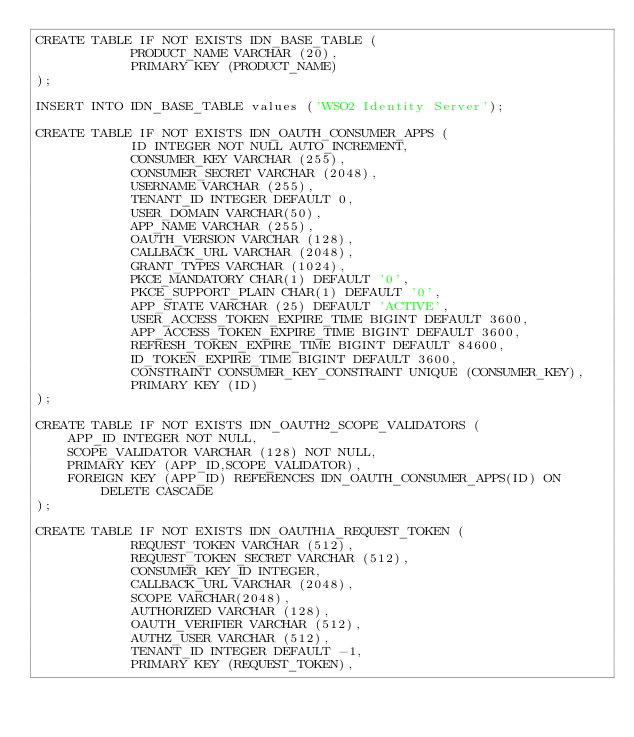<code> <loc_0><loc_0><loc_500><loc_500><_SQL_>CREATE TABLE IF NOT EXISTS IDN_BASE_TABLE (
            PRODUCT_NAME VARCHAR (20),
            PRIMARY KEY (PRODUCT_NAME)
);

INSERT INTO IDN_BASE_TABLE values ('WSO2 Identity Server');

CREATE TABLE IF NOT EXISTS IDN_OAUTH_CONSUMER_APPS (
            ID INTEGER NOT NULL AUTO_INCREMENT,
            CONSUMER_KEY VARCHAR (255),
            CONSUMER_SECRET VARCHAR (2048),
            USERNAME VARCHAR (255),
            TENANT_ID INTEGER DEFAULT 0,
            USER_DOMAIN VARCHAR(50),
            APP_NAME VARCHAR (255),
            OAUTH_VERSION VARCHAR (128),
            CALLBACK_URL VARCHAR (2048),
            GRANT_TYPES VARCHAR (1024),
            PKCE_MANDATORY CHAR(1) DEFAULT '0',
            PKCE_SUPPORT_PLAIN CHAR(1) DEFAULT '0',
            APP_STATE VARCHAR (25) DEFAULT 'ACTIVE',
            USER_ACCESS_TOKEN_EXPIRE_TIME BIGINT DEFAULT 3600,
            APP_ACCESS_TOKEN_EXPIRE_TIME BIGINT DEFAULT 3600,
            REFRESH_TOKEN_EXPIRE_TIME BIGINT DEFAULT 84600,
            ID_TOKEN_EXPIRE_TIME BIGINT DEFAULT 3600,
            CONSTRAINT CONSUMER_KEY_CONSTRAINT UNIQUE (CONSUMER_KEY),
            PRIMARY KEY (ID)
);

CREATE TABLE IF NOT EXISTS IDN_OAUTH2_SCOPE_VALIDATORS (
	APP_ID INTEGER NOT NULL,
	SCOPE_VALIDATOR VARCHAR (128) NOT NULL,
	PRIMARY KEY (APP_ID,SCOPE_VALIDATOR),
	FOREIGN KEY (APP_ID) REFERENCES IDN_OAUTH_CONSUMER_APPS(ID) ON DELETE CASCADE
);

CREATE TABLE IF NOT EXISTS IDN_OAUTH1A_REQUEST_TOKEN (
            REQUEST_TOKEN VARCHAR (512),
            REQUEST_TOKEN_SECRET VARCHAR (512),
            CONSUMER_KEY_ID INTEGER,
            CALLBACK_URL VARCHAR (2048),
            SCOPE VARCHAR(2048),
            AUTHORIZED VARCHAR (128),
            OAUTH_VERIFIER VARCHAR (512),
            AUTHZ_USER VARCHAR (512),
            TENANT_ID INTEGER DEFAULT -1,
            PRIMARY KEY (REQUEST_TOKEN),</code> 